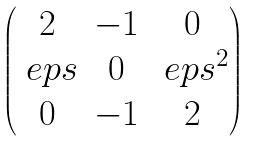Convert formula to latex. <formula><loc_0><loc_0><loc_500><loc_500>\begin{pmatrix} 2 & - 1 & 0 \\ \ e p s & 0 & \ e p s ^ { 2 } \\ 0 & - 1 & 2 \end{pmatrix}</formula> 